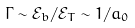<formula> <loc_0><loc_0><loc_500><loc_500>\Gamma \sim \mathcal { E } _ { b } / \mathcal { E } _ { T } \sim 1 / a _ { 0 }</formula> 